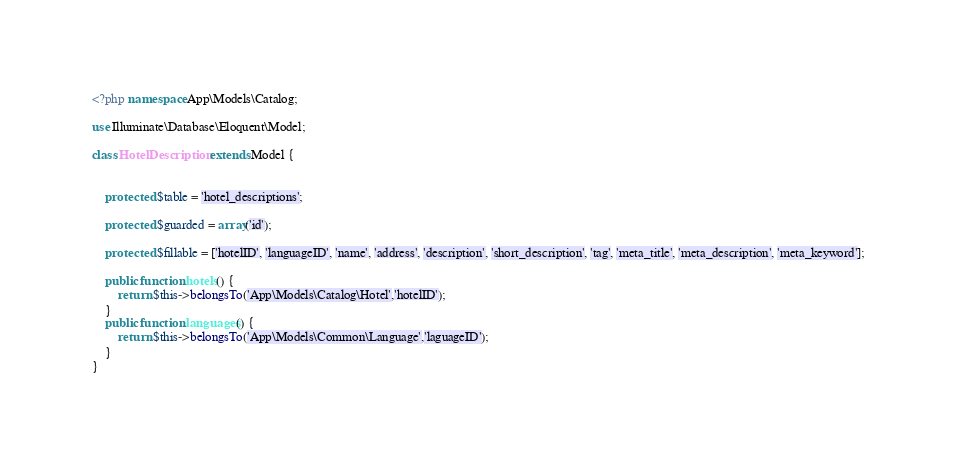<code> <loc_0><loc_0><loc_500><loc_500><_PHP_><?php namespace App\Models\Catalog;

use Illuminate\Database\Eloquent\Model;

class HotelDescription extends Model {


	protected $table = 'hotel_descriptions';
        
    protected $guarded = array('id');

	protected $fillable = ['hotelID', 'languageID', 'name', 'address', 'description', 'short_description', 'tag', 'meta_title', 'meta_description', 'meta_keyword'];

    public function hotels() {
        return $this->belongsTo('App\Models\Catalog\Hotel','hotelID');
    }
    public function languages() {
        return $this->belongsTo('App\Models\Common\Language','laguageID');
    }
}
</code> 